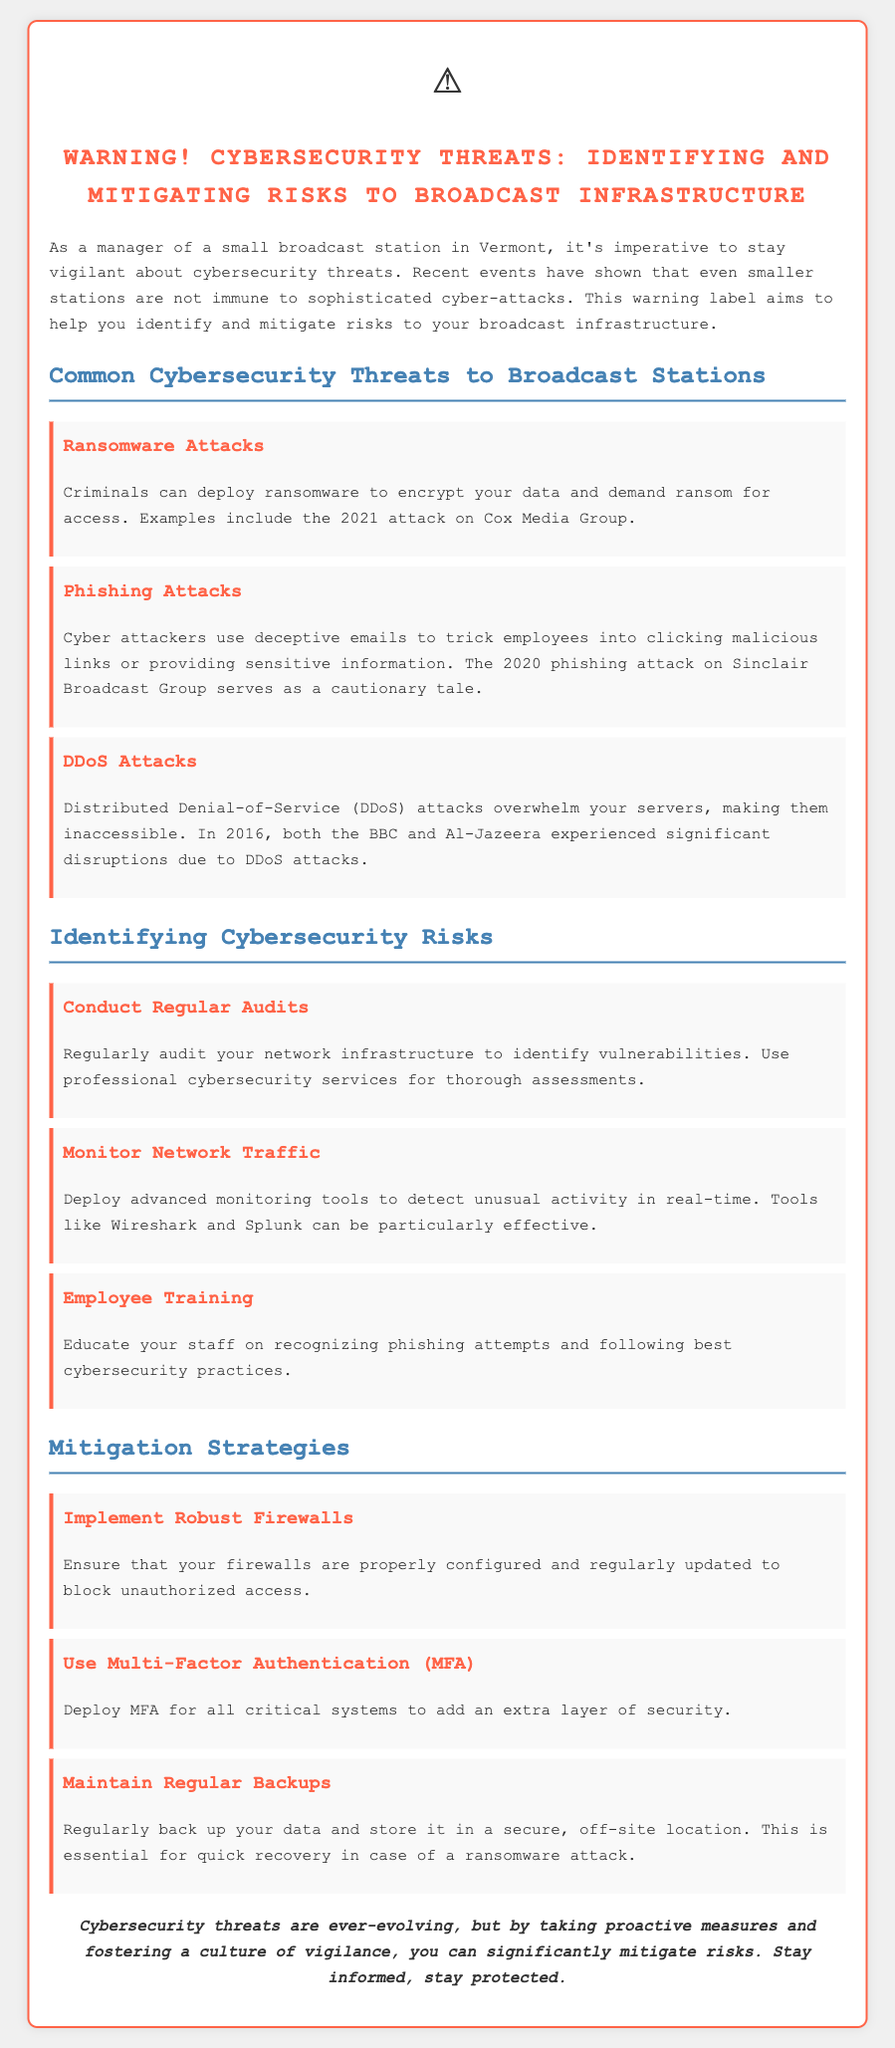What is the title of the document? The title of the document is the main heading at the top, which states the purpose of the label.
Answer: Warning! Cybersecurity Threats: Identifying and Mitigating Risks to Broadcast Infrastructure What attack type is mentioned as affecting Cox Media Group? The document includes specific examples of ransomware attacks, highlighting the incident involving Cox Media Group.
Answer: Ransomware Attacks Which monitoring tool is suggested for detecting unusual activity? The document mentions advanced monitoring tools for real-time detection, including the name of one specific tool.
Answer: Wireshark What strategy is recommended for data security against ransomware? The document emphasizes the importance of regularly backing up data as a mitigation strategy for ransomware attacks.
Answer: Maintain Regular Backups How many common cybersecurity threats are identified in the document? The document lists three specific common threats faced by broadcast stations.
Answer: Three What type of authentication is advised to enhance security for critical systems? The document recommends the use of an additional security measure for critical systems to enhance protection.
Answer: Multi-Factor Authentication (MFA) What is the main implication of the conclusion? The conclusion summarizes the overall tone of the document regarding the proactive measures needed for cybersecurity.
Answer: Stay informed, stay protected 